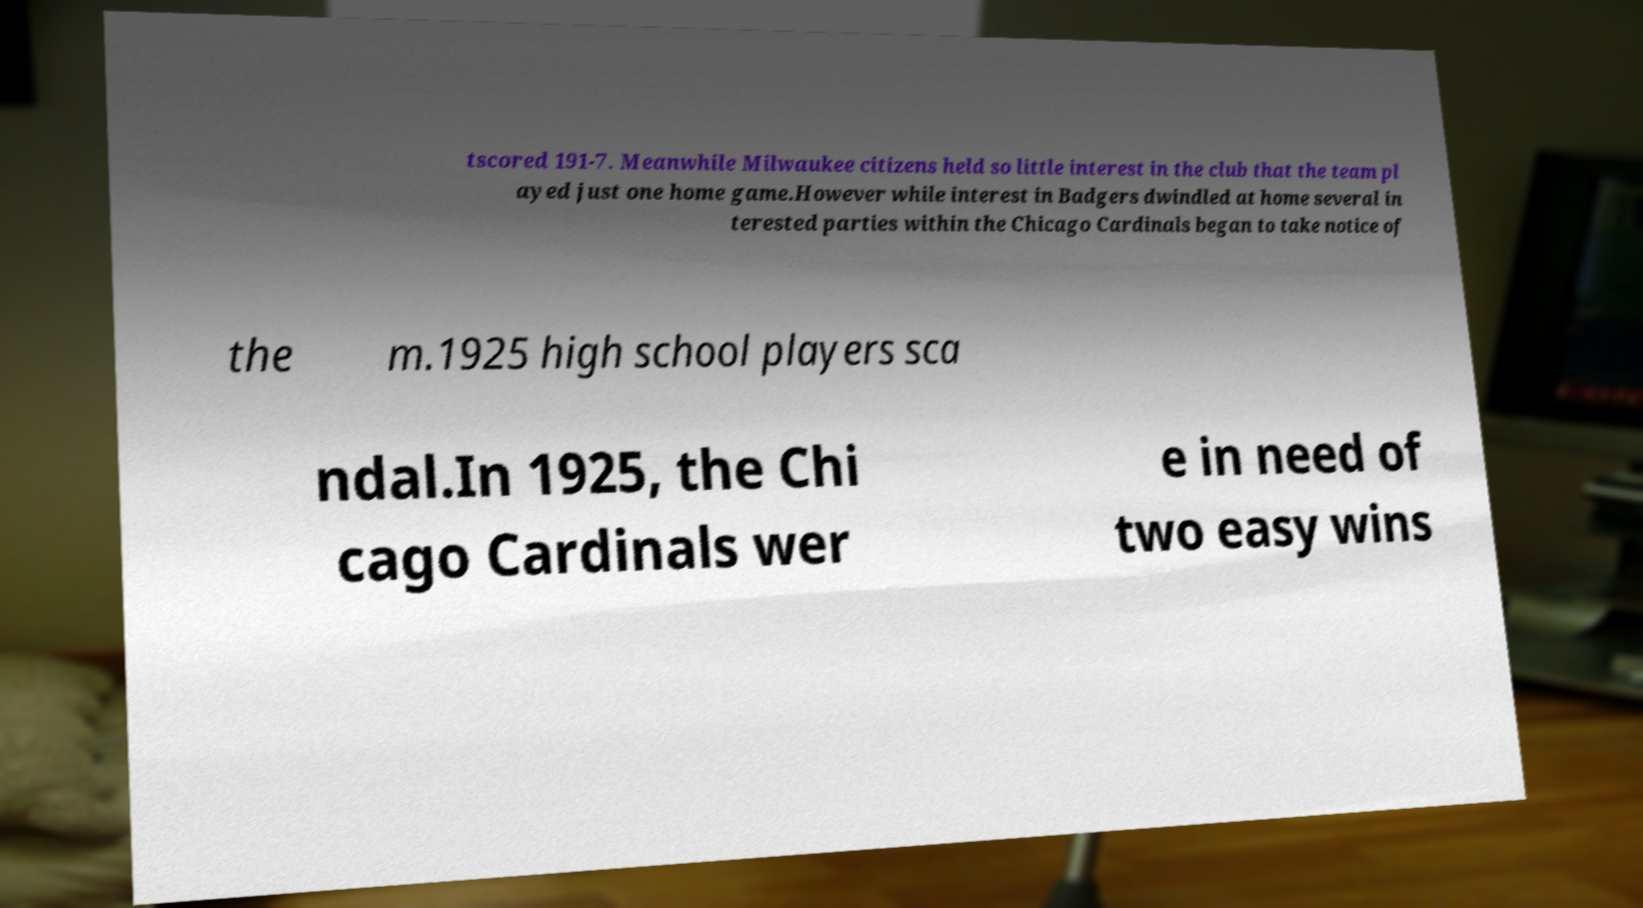Could you assist in decoding the text presented in this image and type it out clearly? tscored 191-7. Meanwhile Milwaukee citizens held so little interest in the club that the team pl ayed just one home game.However while interest in Badgers dwindled at home several in terested parties within the Chicago Cardinals began to take notice of the m.1925 high school players sca ndal.In 1925, the Chi cago Cardinals wer e in need of two easy wins 